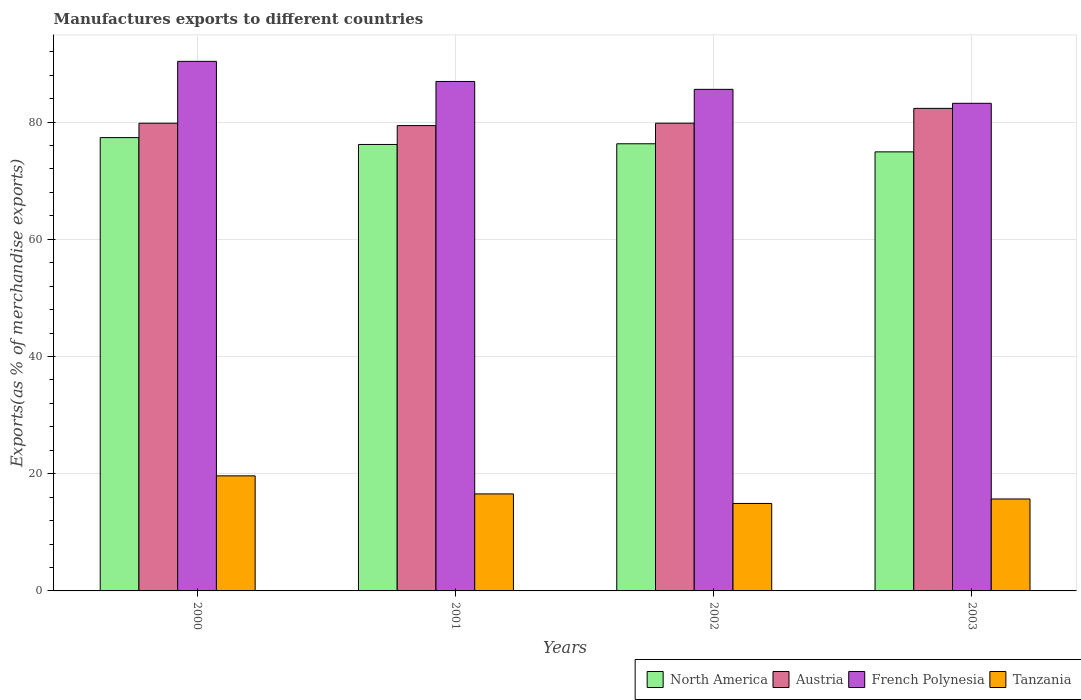How many different coloured bars are there?
Offer a very short reply. 4. Are the number of bars per tick equal to the number of legend labels?
Keep it short and to the point. Yes. Are the number of bars on each tick of the X-axis equal?
Ensure brevity in your answer.  Yes. How many bars are there on the 3rd tick from the left?
Give a very brief answer. 4. How many bars are there on the 2nd tick from the right?
Provide a short and direct response. 4. What is the label of the 3rd group of bars from the left?
Ensure brevity in your answer.  2002. What is the percentage of exports to different countries in North America in 2003?
Your answer should be very brief. 74.9. Across all years, what is the maximum percentage of exports to different countries in Tanzania?
Make the answer very short. 19.63. Across all years, what is the minimum percentage of exports to different countries in Tanzania?
Keep it short and to the point. 14.92. In which year was the percentage of exports to different countries in French Polynesia minimum?
Your answer should be compact. 2003. What is the total percentage of exports to different countries in Tanzania in the graph?
Make the answer very short. 66.79. What is the difference between the percentage of exports to different countries in French Polynesia in 2001 and that in 2002?
Make the answer very short. 1.35. What is the difference between the percentage of exports to different countries in Austria in 2000 and the percentage of exports to different countries in Tanzania in 2002?
Your answer should be very brief. 64.87. What is the average percentage of exports to different countries in Austria per year?
Your answer should be compact. 80.33. In the year 2000, what is the difference between the percentage of exports to different countries in Austria and percentage of exports to different countries in North America?
Your answer should be compact. 2.45. In how many years, is the percentage of exports to different countries in Austria greater than 64 %?
Your response must be concise. 4. What is the ratio of the percentage of exports to different countries in Austria in 2001 to that in 2002?
Your answer should be compact. 0.99. What is the difference between the highest and the second highest percentage of exports to different countries in Austria?
Offer a terse response. 2.53. What is the difference between the highest and the lowest percentage of exports to different countries in Austria?
Make the answer very short. 2.94. In how many years, is the percentage of exports to different countries in Tanzania greater than the average percentage of exports to different countries in Tanzania taken over all years?
Keep it short and to the point. 1. Is it the case that in every year, the sum of the percentage of exports to different countries in North America and percentage of exports to different countries in Tanzania is greater than the sum of percentage of exports to different countries in French Polynesia and percentage of exports to different countries in Austria?
Make the answer very short. No. What does the 2nd bar from the left in 2002 represents?
Your answer should be very brief. Austria. What does the 2nd bar from the right in 2003 represents?
Make the answer very short. French Polynesia. Is it the case that in every year, the sum of the percentage of exports to different countries in Tanzania and percentage of exports to different countries in Austria is greater than the percentage of exports to different countries in French Polynesia?
Your response must be concise. Yes. Are all the bars in the graph horizontal?
Make the answer very short. No. What is the difference between two consecutive major ticks on the Y-axis?
Offer a terse response. 20. Are the values on the major ticks of Y-axis written in scientific E-notation?
Your answer should be very brief. No. Does the graph contain grids?
Keep it short and to the point. Yes. How many legend labels are there?
Offer a very short reply. 4. How are the legend labels stacked?
Make the answer very short. Horizontal. What is the title of the graph?
Give a very brief answer. Manufactures exports to different countries. Does "Austria" appear as one of the legend labels in the graph?
Offer a terse response. Yes. What is the label or title of the Y-axis?
Provide a succinct answer. Exports(as % of merchandise exports). What is the Exports(as % of merchandise exports) in North America in 2000?
Ensure brevity in your answer.  77.34. What is the Exports(as % of merchandise exports) in Austria in 2000?
Offer a terse response. 79.79. What is the Exports(as % of merchandise exports) of French Polynesia in 2000?
Make the answer very short. 90.35. What is the Exports(as % of merchandise exports) in Tanzania in 2000?
Ensure brevity in your answer.  19.63. What is the Exports(as % of merchandise exports) of North America in 2001?
Keep it short and to the point. 76.17. What is the Exports(as % of merchandise exports) of Austria in 2001?
Provide a succinct answer. 79.39. What is the Exports(as % of merchandise exports) in French Polynesia in 2001?
Provide a succinct answer. 86.92. What is the Exports(as % of merchandise exports) in Tanzania in 2001?
Offer a terse response. 16.55. What is the Exports(as % of merchandise exports) of North America in 2002?
Your answer should be very brief. 76.29. What is the Exports(as % of merchandise exports) of Austria in 2002?
Offer a terse response. 79.8. What is the Exports(as % of merchandise exports) in French Polynesia in 2002?
Make the answer very short. 85.57. What is the Exports(as % of merchandise exports) of Tanzania in 2002?
Keep it short and to the point. 14.92. What is the Exports(as % of merchandise exports) in North America in 2003?
Your answer should be very brief. 74.9. What is the Exports(as % of merchandise exports) of Austria in 2003?
Provide a short and direct response. 82.32. What is the Exports(as % of merchandise exports) in French Polynesia in 2003?
Provide a short and direct response. 83.19. What is the Exports(as % of merchandise exports) of Tanzania in 2003?
Offer a very short reply. 15.69. Across all years, what is the maximum Exports(as % of merchandise exports) of North America?
Your answer should be compact. 77.34. Across all years, what is the maximum Exports(as % of merchandise exports) in Austria?
Offer a terse response. 82.32. Across all years, what is the maximum Exports(as % of merchandise exports) of French Polynesia?
Ensure brevity in your answer.  90.35. Across all years, what is the maximum Exports(as % of merchandise exports) of Tanzania?
Give a very brief answer. 19.63. Across all years, what is the minimum Exports(as % of merchandise exports) of North America?
Ensure brevity in your answer.  74.9. Across all years, what is the minimum Exports(as % of merchandise exports) in Austria?
Offer a very short reply. 79.39. Across all years, what is the minimum Exports(as % of merchandise exports) in French Polynesia?
Make the answer very short. 83.19. Across all years, what is the minimum Exports(as % of merchandise exports) of Tanzania?
Provide a short and direct response. 14.92. What is the total Exports(as % of merchandise exports) in North America in the graph?
Your response must be concise. 304.7. What is the total Exports(as % of merchandise exports) of Austria in the graph?
Offer a very short reply. 321.3. What is the total Exports(as % of merchandise exports) of French Polynesia in the graph?
Keep it short and to the point. 346.03. What is the total Exports(as % of merchandise exports) in Tanzania in the graph?
Keep it short and to the point. 66.79. What is the difference between the Exports(as % of merchandise exports) of North America in 2000 and that in 2001?
Provide a succinct answer. 1.17. What is the difference between the Exports(as % of merchandise exports) of Austria in 2000 and that in 2001?
Keep it short and to the point. 0.41. What is the difference between the Exports(as % of merchandise exports) of French Polynesia in 2000 and that in 2001?
Provide a short and direct response. 3.43. What is the difference between the Exports(as % of merchandise exports) of Tanzania in 2000 and that in 2001?
Make the answer very short. 3.08. What is the difference between the Exports(as % of merchandise exports) in North America in 2000 and that in 2002?
Make the answer very short. 1.05. What is the difference between the Exports(as % of merchandise exports) in Austria in 2000 and that in 2002?
Your answer should be compact. -0.01. What is the difference between the Exports(as % of merchandise exports) in French Polynesia in 2000 and that in 2002?
Make the answer very short. 4.78. What is the difference between the Exports(as % of merchandise exports) in Tanzania in 2000 and that in 2002?
Your response must be concise. 4.71. What is the difference between the Exports(as % of merchandise exports) in North America in 2000 and that in 2003?
Your answer should be very brief. 2.43. What is the difference between the Exports(as % of merchandise exports) in Austria in 2000 and that in 2003?
Give a very brief answer. -2.53. What is the difference between the Exports(as % of merchandise exports) in French Polynesia in 2000 and that in 2003?
Keep it short and to the point. 7.16. What is the difference between the Exports(as % of merchandise exports) in Tanzania in 2000 and that in 2003?
Give a very brief answer. 3.95. What is the difference between the Exports(as % of merchandise exports) of North America in 2001 and that in 2002?
Make the answer very short. -0.12. What is the difference between the Exports(as % of merchandise exports) in Austria in 2001 and that in 2002?
Ensure brevity in your answer.  -0.41. What is the difference between the Exports(as % of merchandise exports) in French Polynesia in 2001 and that in 2002?
Your response must be concise. 1.35. What is the difference between the Exports(as % of merchandise exports) of Tanzania in 2001 and that in 2002?
Offer a terse response. 1.63. What is the difference between the Exports(as % of merchandise exports) in North America in 2001 and that in 2003?
Provide a short and direct response. 1.27. What is the difference between the Exports(as % of merchandise exports) of Austria in 2001 and that in 2003?
Your answer should be compact. -2.94. What is the difference between the Exports(as % of merchandise exports) of French Polynesia in 2001 and that in 2003?
Keep it short and to the point. 3.73. What is the difference between the Exports(as % of merchandise exports) in Tanzania in 2001 and that in 2003?
Provide a short and direct response. 0.87. What is the difference between the Exports(as % of merchandise exports) in North America in 2002 and that in 2003?
Provide a short and direct response. 1.38. What is the difference between the Exports(as % of merchandise exports) in Austria in 2002 and that in 2003?
Your response must be concise. -2.53. What is the difference between the Exports(as % of merchandise exports) of French Polynesia in 2002 and that in 2003?
Give a very brief answer. 2.38. What is the difference between the Exports(as % of merchandise exports) in Tanzania in 2002 and that in 2003?
Provide a short and direct response. -0.76. What is the difference between the Exports(as % of merchandise exports) of North America in 2000 and the Exports(as % of merchandise exports) of Austria in 2001?
Keep it short and to the point. -2.05. What is the difference between the Exports(as % of merchandise exports) of North America in 2000 and the Exports(as % of merchandise exports) of French Polynesia in 2001?
Give a very brief answer. -9.58. What is the difference between the Exports(as % of merchandise exports) of North America in 2000 and the Exports(as % of merchandise exports) of Tanzania in 2001?
Offer a terse response. 60.79. What is the difference between the Exports(as % of merchandise exports) of Austria in 2000 and the Exports(as % of merchandise exports) of French Polynesia in 2001?
Your answer should be very brief. -7.12. What is the difference between the Exports(as % of merchandise exports) in Austria in 2000 and the Exports(as % of merchandise exports) in Tanzania in 2001?
Offer a very short reply. 63.24. What is the difference between the Exports(as % of merchandise exports) in French Polynesia in 2000 and the Exports(as % of merchandise exports) in Tanzania in 2001?
Give a very brief answer. 73.8. What is the difference between the Exports(as % of merchandise exports) of North America in 2000 and the Exports(as % of merchandise exports) of Austria in 2002?
Provide a short and direct response. -2.46. What is the difference between the Exports(as % of merchandise exports) of North America in 2000 and the Exports(as % of merchandise exports) of French Polynesia in 2002?
Ensure brevity in your answer.  -8.23. What is the difference between the Exports(as % of merchandise exports) in North America in 2000 and the Exports(as % of merchandise exports) in Tanzania in 2002?
Offer a terse response. 62.42. What is the difference between the Exports(as % of merchandise exports) in Austria in 2000 and the Exports(as % of merchandise exports) in French Polynesia in 2002?
Your answer should be compact. -5.78. What is the difference between the Exports(as % of merchandise exports) of Austria in 2000 and the Exports(as % of merchandise exports) of Tanzania in 2002?
Your answer should be compact. 64.87. What is the difference between the Exports(as % of merchandise exports) in French Polynesia in 2000 and the Exports(as % of merchandise exports) in Tanzania in 2002?
Provide a short and direct response. 75.43. What is the difference between the Exports(as % of merchandise exports) in North America in 2000 and the Exports(as % of merchandise exports) in Austria in 2003?
Keep it short and to the point. -4.99. What is the difference between the Exports(as % of merchandise exports) of North America in 2000 and the Exports(as % of merchandise exports) of French Polynesia in 2003?
Ensure brevity in your answer.  -5.85. What is the difference between the Exports(as % of merchandise exports) of North America in 2000 and the Exports(as % of merchandise exports) of Tanzania in 2003?
Offer a terse response. 61.65. What is the difference between the Exports(as % of merchandise exports) in Austria in 2000 and the Exports(as % of merchandise exports) in French Polynesia in 2003?
Provide a succinct answer. -3.4. What is the difference between the Exports(as % of merchandise exports) in Austria in 2000 and the Exports(as % of merchandise exports) in Tanzania in 2003?
Provide a short and direct response. 64.11. What is the difference between the Exports(as % of merchandise exports) in French Polynesia in 2000 and the Exports(as % of merchandise exports) in Tanzania in 2003?
Offer a very short reply. 74.66. What is the difference between the Exports(as % of merchandise exports) in North America in 2001 and the Exports(as % of merchandise exports) in Austria in 2002?
Provide a succinct answer. -3.63. What is the difference between the Exports(as % of merchandise exports) in North America in 2001 and the Exports(as % of merchandise exports) in French Polynesia in 2002?
Provide a short and direct response. -9.4. What is the difference between the Exports(as % of merchandise exports) of North America in 2001 and the Exports(as % of merchandise exports) of Tanzania in 2002?
Provide a succinct answer. 61.25. What is the difference between the Exports(as % of merchandise exports) in Austria in 2001 and the Exports(as % of merchandise exports) in French Polynesia in 2002?
Keep it short and to the point. -6.18. What is the difference between the Exports(as % of merchandise exports) in Austria in 2001 and the Exports(as % of merchandise exports) in Tanzania in 2002?
Ensure brevity in your answer.  64.46. What is the difference between the Exports(as % of merchandise exports) of French Polynesia in 2001 and the Exports(as % of merchandise exports) of Tanzania in 2002?
Ensure brevity in your answer.  71.99. What is the difference between the Exports(as % of merchandise exports) of North America in 2001 and the Exports(as % of merchandise exports) of Austria in 2003?
Your response must be concise. -6.15. What is the difference between the Exports(as % of merchandise exports) of North America in 2001 and the Exports(as % of merchandise exports) of French Polynesia in 2003?
Your response must be concise. -7.02. What is the difference between the Exports(as % of merchandise exports) of North America in 2001 and the Exports(as % of merchandise exports) of Tanzania in 2003?
Make the answer very short. 60.48. What is the difference between the Exports(as % of merchandise exports) in Austria in 2001 and the Exports(as % of merchandise exports) in French Polynesia in 2003?
Keep it short and to the point. -3.8. What is the difference between the Exports(as % of merchandise exports) of Austria in 2001 and the Exports(as % of merchandise exports) of Tanzania in 2003?
Give a very brief answer. 63.7. What is the difference between the Exports(as % of merchandise exports) of French Polynesia in 2001 and the Exports(as % of merchandise exports) of Tanzania in 2003?
Give a very brief answer. 71.23. What is the difference between the Exports(as % of merchandise exports) in North America in 2002 and the Exports(as % of merchandise exports) in Austria in 2003?
Provide a succinct answer. -6.04. What is the difference between the Exports(as % of merchandise exports) of North America in 2002 and the Exports(as % of merchandise exports) of French Polynesia in 2003?
Provide a short and direct response. -6.9. What is the difference between the Exports(as % of merchandise exports) in North America in 2002 and the Exports(as % of merchandise exports) in Tanzania in 2003?
Offer a terse response. 60.6. What is the difference between the Exports(as % of merchandise exports) in Austria in 2002 and the Exports(as % of merchandise exports) in French Polynesia in 2003?
Offer a terse response. -3.39. What is the difference between the Exports(as % of merchandise exports) of Austria in 2002 and the Exports(as % of merchandise exports) of Tanzania in 2003?
Make the answer very short. 64.11. What is the difference between the Exports(as % of merchandise exports) in French Polynesia in 2002 and the Exports(as % of merchandise exports) in Tanzania in 2003?
Offer a terse response. 69.89. What is the average Exports(as % of merchandise exports) in North America per year?
Make the answer very short. 76.17. What is the average Exports(as % of merchandise exports) in Austria per year?
Provide a short and direct response. 80.33. What is the average Exports(as % of merchandise exports) in French Polynesia per year?
Your response must be concise. 86.51. What is the average Exports(as % of merchandise exports) of Tanzania per year?
Make the answer very short. 16.7. In the year 2000, what is the difference between the Exports(as % of merchandise exports) in North America and Exports(as % of merchandise exports) in Austria?
Make the answer very short. -2.45. In the year 2000, what is the difference between the Exports(as % of merchandise exports) of North America and Exports(as % of merchandise exports) of French Polynesia?
Keep it short and to the point. -13.01. In the year 2000, what is the difference between the Exports(as % of merchandise exports) of North America and Exports(as % of merchandise exports) of Tanzania?
Ensure brevity in your answer.  57.71. In the year 2000, what is the difference between the Exports(as % of merchandise exports) of Austria and Exports(as % of merchandise exports) of French Polynesia?
Provide a short and direct response. -10.56. In the year 2000, what is the difference between the Exports(as % of merchandise exports) in Austria and Exports(as % of merchandise exports) in Tanzania?
Make the answer very short. 60.16. In the year 2000, what is the difference between the Exports(as % of merchandise exports) in French Polynesia and Exports(as % of merchandise exports) in Tanzania?
Provide a short and direct response. 70.72. In the year 2001, what is the difference between the Exports(as % of merchandise exports) in North America and Exports(as % of merchandise exports) in Austria?
Give a very brief answer. -3.22. In the year 2001, what is the difference between the Exports(as % of merchandise exports) in North America and Exports(as % of merchandise exports) in French Polynesia?
Ensure brevity in your answer.  -10.75. In the year 2001, what is the difference between the Exports(as % of merchandise exports) of North America and Exports(as % of merchandise exports) of Tanzania?
Your response must be concise. 59.62. In the year 2001, what is the difference between the Exports(as % of merchandise exports) of Austria and Exports(as % of merchandise exports) of French Polynesia?
Your answer should be compact. -7.53. In the year 2001, what is the difference between the Exports(as % of merchandise exports) of Austria and Exports(as % of merchandise exports) of Tanzania?
Offer a very short reply. 62.83. In the year 2001, what is the difference between the Exports(as % of merchandise exports) of French Polynesia and Exports(as % of merchandise exports) of Tanzania?
Provide a succinct answer. 70.36. In the year 2002, what is the difference between the Exports(as % of merchandise exports) of North America and Exports(as % of merchandise exports) of Austria?
Make the answer very short. -3.51. In the year 2002, what is the difference between the Exports(as % of merchandise exports) of North America and Exports(as % of merchandise exports) of French Polynesia?
Give a very brief answer. -9.28. In the year 2002, what is the difference between the Exports(as % of merchandise exports) in North America and Exports(as % of merchandise exports) in Tanzania?
Offer a very short reply. 61.36. In the year 2002, what is the difference between the Exports(as % of merchandise exports) of Austria and Exports(as % of merchandise exports) of French Polynesia?
Offer a very short reply. -5.77. In the year 2002, what is the difference between the Exports(as % of merchandise exports) of Austria and Exports(as % of merchandise exports) of Tanzania?
Provide a short and direct response. 64.88. In the year 2002, what is the difference between the Exports(as % of merchandise exports) of French Polynesia and Exports(as % of merchandise exports) of Tanzania?
Make the answer very short. 70.65. In the year 2003, what is the difference between the Exports(as % of merchandise exports) in North America and Exports(as % of merchandise exports) in Austria?
Your answer should be very brief. -7.42. In the year 2003, what is the difference between the Exports(as % of merchandise exports) of North America and Exports(as % of merchandise exports) of French Polynesia?
Give a very brief answer. -8.29. In the year 2003, what is the difference between the Exports(as % of merchandise exports) in North America and Exports(as % of merchandise exports) in Tanzania?
Offer a very short reply. 59.22. In the year 2003, what is the difference between the Exports(as % of merchandise exports) in Austria and Exports(as % of merchandise exports) in French Polynesia?
Offer a very short reply. -0.87. In the year 2003, what is the difference between the Exports(as % of merchandise exports) of Austria and Exports(as % of merchandise exports) of Tanzania?
Keep it short and to the point. 66.64. In the year 2003, what is the difference between the Exports(as % of merchandise exports) in French Polynesia and Exports(as % of merchandise exports) in Tanzania?
Your response must be concise. 67.51. What is the ratio of the Exports(as % of merchandise exports) in North America in 2000 to that in 2001?
Your answer should be very brief. 1.02. What is the ratio of the Exports(as % of merchandise exports) of French Polynesia in 2000 to that in 2001?
Your answer should be very brief. 1.04. What is the ratio of the Exports(as % of merchandise exports) in Tanzania in 2000 to that in 2001?
Ensure brevity in your answer.  1.19. What is the ratio of the Exports(as % of merchandise exports) of North America in 2000 to that in 2002?
Your answer should be very brief. 1.01. What is the ratio of the Exports(as % of merchandise exports) of Austria in 2000 to that in 2002?
Your answer should be very brief. 1. What is the ratio of the Exports(as % of merchandise exports) of French Polynesia in 2000 to that in 2002?
Make the answer very short. 1.06. What is the ratio of the Exports(as % of merchandise exports) of Tanzania in 2000 to that in 2002?
Your response must be concise. 1.32. What is the ratio of the Exports(as % of merchandise exports) in North America in 2000 to that in 2003?
Give a very brief answer. 1.03. What is the ratio of the Exports(as % of merchandise exports) in Austria in 2000 to that in 2003?
Your answer should be compact. 0.97. What is the ratio of the Exports(as % of merchandise exports) of French Polynesia in 2000 to that in 2003?
Provide a short and direct response. 1.09. What is the ratio of the Exports(as % of merchandise exports) in Tanzania in 2000 to that in 2003?
Your answer should be compact. 1.25. What is the ratio of the Exports(as % of merchandise exports) in French Polynesia in 2001 to that in 2002?
Keep it short and to the point. 1.02. What is the ratio of the Exports(as % of merchandise exports) of Tanzania in 2001 to that in 2002?
Offer a terse response. 1.11. What is the ratio of the Exports(as % of merchandise exports) in North America in 2001 to that in 2003?
Ensure brevity in your answer.  1.02. What is the ratio of the Exports(as % of merchandise exports) in French Polynesia in 2001 to that in 2003?
Your answer should be very brief. 1.04. What is the ratio of the Exports(as % of merchandise exports) of Tanzania in 2001 to that in 2003?
Your answer should be compact. 1.06. What is the ratio of the Exports(as % of merchandise exports) of North America in 2002 to that in 2003?
Offer a terse response. 1.02. What is the ratio of the Exports(as % of merchandise exports) in Austria in 2002 to that in 2003?
Your response must be concise. 0.97. What is the ratio of the Exports(as % of merchandise exports) in French Polynesia in 2002 to that in 2003?
Keep it short and to the point. 1.03. What is the ratio of the Exports(as % of merchandise exports) in Tanzania in 2002 to that in 2003?
Give a very brief answer. 0.95. What is the difference between the highest and the second highest Exports(as % of merchandise exports) of North America?
Make the answer very short. 1.05. What is the difference between the highest and the second highest Exports(as % of merchandise exports) in Austria?
Give a very brief answer. 2.53. What is the difference between the highest and the second highest Exports(as % of merchandise exports) in French Polynesia?
Your response must be concise. 3.43. What is the difference between the highest and the second highest Exports(as % of merchandise exports) in Tanzania?
Offer a very short reply. 3.08. What is the difference between the highest and the lowest Exports(as % of merchandise exports) in North America?
Give a very brief answer. 2.43. What is the difference between the highest and the lowest Exports(as % of merchandise exports) in Austria?
Ensure brevity in your answer.  2.94. What is the difference between the highest and the lowest Exports(as % of merchandise exports) in French Polynesia?
Your response must be concise. 7.16. What is the difference between the highest and the lowest Exports(as % of merchandise exports) of Tanzania?
Make the answer very short. 4.71. 